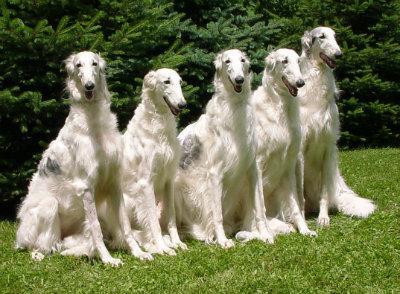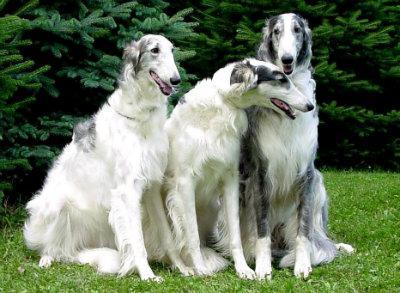The first image is the image on the left, the second image is the image on the right. Considering the images on both sides, is "Right image shows exactly one black and white hound in profile." valid? Answer yes or no. No. The first image is the image on the left, the second image is the image on the right. Considering the images on both sides, is "The dog in the image on the left is standing in profile facing the left." valid? Answer yes or no. No. 